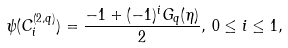<formula> <loc_0><loc_0><loc_500><loc_500>\psi ( C _ { i } ^ { ( 2 , q ) } ) = \frac { - 1 + ( - 1 ) ^ { i } G _ { q } ( \eta ) } { 2 } , \, 0 \leq i \leq 1 ,</formula> 